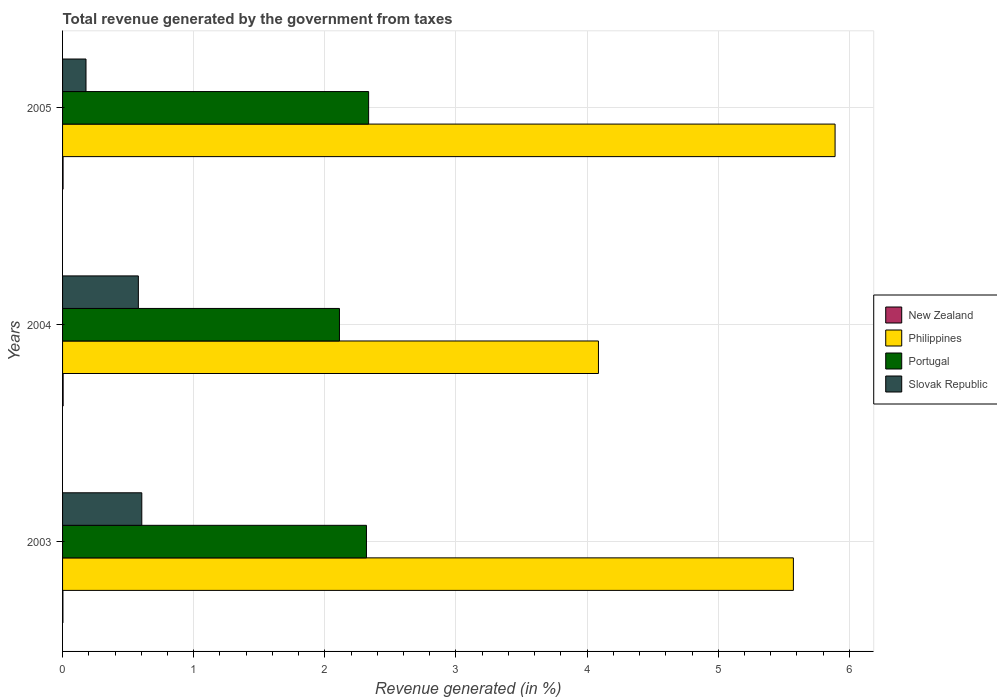How many different coloured bars are there?
Provide a succinct answer. 4. Are the number of bars per tick equal to the number of legend labels?
Offer a terse response. Yes. How many bars are there on the 2nd tick from the top?
Make the answer very short. 4. How many bars are there on the 1st tick from the bottom?
Your answer should be compact. 4. What is the label of the 2nd group of bars from the top?
Ensure brevity in your answer.  2004. What is the total revenue generated in New Zealand in 2004?
Your answer should be very brief. 0. Across all years, what is the maximum total revenue generated in Portugal?
Your answer should be compact. 2.33. Across all years, what is the minimum total revenue generated in Slovak Republic?
Make the answer very short. 0.18. In which year was the total revenue generated in New Zealand minimum?
Provide a short and direct response. 2003. What is the total total revenue generated in Philippines in the graph?
Your answer should be compact. 15.55. What is the difference between the total revenue generated in New Zealand in 2003 and that in 2005?
Your response must be concise. -0. What is the difference between the total revenue generated in Slovak Republic in 2005 and the total revenue generated in New Zealand in 2003?
Offer a terse response. 0.18. What is the average total revenue generated in Portugal per year?
Offer a very short reply. 2.25. In the year 2004, what is the difference between the total revenue generated in Slovak Republic and total revenue generated in New Zealand?
Your answer should be very brief. 0.57. In how many years, is the total revenue generated in New Zealand greater than 5.4 %?
Offer a very short reply. 0. What is the ratio of the total revenue generated in Philippines in 2003 to that in 2005?
Offer a terse response. 0.95. Is the total revenue generated in New Zealand in 2003 less than that in 2004?
Make the answer very short. Yes. What is the difference between the highest and the second highest total revenue generated in Portugal?
Ensure brevity in your answer.  0.02. What is the difference between the highest and the lowest total revenue generated in New Zealand?
Your answer should be very brief. 0. Is the sum of the total revenue generated in Philippines in 2003 and 2004 greater than the maximum total revenue generated in New Zealand across all years?
Your answer should be very brief. Yes. Is it the case that in every year, the sum of the total revenue generated in Philippines and total revenue generated in Portugal is greater than the sum of total revenue generated in Slovak Republic and total revenue generated in New Zealand?
Your answer should be compact. Yes. What does the 4th bar from the top in 2005 represents?
Give a very brief answer. New Zealand. What does the 4th bar from the bottom in 2005 represents?
Keep it short and to the point. Slovak Republic. Is it the case that in every year, the sum of the total revenue generated in Slovak Republic and total revenue generated in Philippines is greater than the total revenue generated in Portugal?
Your response must be concise. Yes. How many bars are there?
Offer a terse response. 12. How many years are there in the graph?
Provide a short and direct response. 3. What is the difference between two consecutive major ticks on the X-axis?
Your answer should be compact. 1. Are the values on the major ticks of X-axis written in scientific E-notation?
Ensure brevity in your answer.  No. Does the graph contain any zero values?
Make the answer very short. No. Does the graph contain grids?
Make the answer very short. Yes. What is the title of the graph?
Make the answer very short. Total revenue generated by the government from taxes. Does "Switzerland" appear as one of the legend labels in the graph?
Offer a terse response. No. What is the label or title of the X-axis?
Keep it short and to the point. Revenue generated (in %). What is the label or title of the Y-axis?
Your response must be concise. Years. What is the Revenue generated (in %) of New Zealand in 2003?
Your response must be concise. 0. What is the Revenue generated (in %) of Philippines in 2003?
Your response must be concise. 5.57. What is the Revenue generated (in %) in Portugal in 2003?
Offer a terse response. 2.32. What is the Revenue generated (in %) in Slovak Republic in 2003?
Ensure brevity in your answer.  0.6. What is the Revenue generated (in %) in New Zealand in 2004?
Offer a terse response. 0. What is the Revenue generated (in %) of Philippines in 2004?
Your answer should be compact. 4.09. What is the Revenue generated (in %) of Portugal in 2004?
Make the answer very short. 2.11. What is the Revenue generated (in %) in Slovak Republic in 2004?
Make the answer very short. 0.58. What is the Revenue generated (in %) in New Zealand in 2005?
Give a very brief answer. 0. What is the Revenue generated (in %) in Philippines in 2005?
Your answer should be very brief. 5.89. What is the Revenue generated (in %) in Portugal in 2005?
Make the answer very short. 2.33. What is the Revenue generated (in %) in Slovak Republic in 2005?
Keep it short and to the point. 0.18. Across all years, what is the maximum Revenue generated (in %) in New Zealand?
Your answer should be very brief. 0. Across all years, what is the maximum Revenue generated (in %) in Philippines?
Ensure brevity in your answer.  5.89. Across all years, what is the maximum Revenue generated (in %) of Portugal?
Give a very brief answer. 2.33. Across all years, what is the maximum Revenue generated (in %) of Slovak Republic?
Offer a terse response. 0.6. Across all years, what is the minimum Revenue generated (in %) in New Zealand?
Your answer should be compact. 0. Across all years, what is the minimum Revenue generated (in %) in Philippines?
Offer a very short reply. 4.09. Across all years, what is the minimum Revenue generated (in %) in Portugal?
Keep it short and to the point. 2.11. Across all years, what is the minimum Revenue generated (in %) of Slovak Republic?
Provide a short and direct response. 0.18. What is the total Revenue generated (in %) in New Zealand in the graph?
Your answer should be very brief. 0.01. What is the total Revenue generated (in %) of Philippines in the graph?
Keep it short and to the point. 15.55. What is the total Revenue generated (in %) of Portugal in the graph?
Offer a terse response. 6.76. What is the total Revenue generated (in %) in Slovak Republic in the graph?
Keep it short and to the point. 1.36. What is the difference between the Revenue generated (in %) of New Zealand in 2003 and that in 2004?
Your answer should be very brief. -0. What is the difference between the Revenue generated (in %) of Philippines in 2003 and that in 2004?
Your answer should be very brief. 1.49. What is the difference between the Revenue generated (in %) in Portugal in 2003 and that in 2004?
Your response must be concise. 0.21. What is the difference between the Revenue generated (in %) of Slovak Republic in 2003 and that in 2004?
Make the answer very short. 0.03. What is the difference between the Revenue generated (in %) in New Zealand in 2003 and that in 2005?
Provide a short and direct response. -0. What is the difference between the Revenue generated (in %) in Philippines in 2003 and that in 2005?
Your answer should be very brief. -0.32. What is the difference between the Revenue generated (in %) of Portugal in 2003 and that in 2005?
Ensure brevity in your answer.  -0.02. What is the difference between the Revenue generated (in %) in Slovak Republic in 2003 and that in 2005?
Provide a succinct answer. 0.43. What is the difference between the Revenue generated (in %) in New Zealand in 2004 and that in 2005?
Offer a terse response. 0. What is the difference between the Revenue generated (in %) in Philippines in 2004 and that in 2005?
Provide a short and direct response. -1.8. What is the difference between the Revenue generated (in %) of Portugal in 2004 and that in 2005?
Your response must be concise. -0.22. What is the difference between the Revenue generated (in %) of Slovak Republic in 2004 and that in 2005?
Your answer should be compact. 0.4. What is the difference between the Revenue generated (in %) of New Zealand in 2003 and the Revenue generated (in %) of Philippines in 2004?
Provide a succinct answer. -4.08. What is the difference between the Revenue generated (in %) in New Zealand in 2003 and the Revenue generated (in %) in Portugal in 2004?
Keep it short and to the point. -2.11. What is the difference between the Revenue generated (in %) in New Zealand in 2003 and the Revenue generated (in %) in Slovak Republic in 2004?
Offer a terse response. -0.58. What is the difference between the Revenue generated (in %) in Philippines in 2003 and the Revenue generated (in %) in Portugal in 2004?
Provide a short and direct response. 3.46. What is the difference between the Revenue generated (in %) in Philippines in 2003 and the Revenue generated (in %) in Slovak Republic in 2004?
Your response must be concise. 5. What is the difference between the Revenue generated (in %) of Portugal in 2003 and the Revenue generated (in %) of Slovak Republic in 2004?
Ensure brevity in your answer.  1.74. What is the difference between the Revenue generated (in %) in New Zealand in 2003 and the Revenue generated (in %) in Philippines in 2005?
Make the answer very short. -5.89. What is the difference between the Revenue generated (in %) in New Zealand in 2003 and the Revenue generated (in %) in Portugal in 2005?
Your answer should be very brief. -2.33. What is the difference between the Revenue generated (in %) of New Zealand in 2003 and the Revenue generated (in %) of Slovak Republic in 2005?
Ensure brevity in your answer.  -0.18. What is the difference between the Revenue generated (in %) in Philippines in 2003 and the Revenue generated (in %) in Portugal in 2005?
Your answer should be compact. 3.24. What is the difference between the Revenue generated (in %) in Philippines in 2003 and the Revenue generated (in %) in Slovak Republic in 2005?
Provide a short and direct response. 5.39. What is the difference between the Revenue generated (in %) in Portugal in 2003 and the Revenue generated (in %) in Slovak Republic in 2005?
Your response must be concise. 2.14. What is the difference between the Revenue generated (in %) in New Zealand in 2004 and the Revenue generated (in %) in Philippines in 2005?
Provide a succinct answer. -5.89. What is the difference between the Revenue generated (in %) of New Zealand in 2004 and the Revenue generated (in %) of Portugal in 2005?
Offer a terse response. -2.33. What is the difference between the Revenue generated (in %) of New Zealand in 2004 and the Revenue generated (in %) of Slovak Republic in 2005?
Give a very brief answer. -0.17. What is the difference between the Revenue generated (in %) in Philippines in 2004 and the Revenue generated (in %) in Portugal in 2005?
Give a very brief answer. 1.75. What is the difference between the Revenue generated (in %) of Philippines in 2004 and the Revenue generated (in %) of Slovak Republic in 2005?
Provide a short and direct response. 3.91. What is the difference between the Revenue generated (in %) in Portugal in 2004 and the Revenue generated (in %) in Slovak Republic in 2005?
Make the answer very short. 1.93. What is the average Revenue generated (in %) of New Zealand per year?
Your response must be concise. 0. What is the average Revenue generated (in %) in Philippines per year?
Offer a terse response. 5.18. What is the average Revenue generated (in %) in Portugal per year?
Your answer should be compact. 2.25. What is the average Revenue generated (in %) of Slovak Republic per year?
Your answer should be very brief. 0.45. In the year 2003, what is the difference between the Revenue generated (in %) in New Zealand and Revenue generated (in %) in Philippines?
Provide a short and direct response. -5.57. In the year 2003, what is the difference between the Revenue generated (in %) of New Zealand and Revenue generated (in %) of Portugal?
Give a very brief answer. -2.31. In the year 2003, what is the difference between the Revenue generated (in %) of New Zealand and Revenue generated (in %) of Slovak Republic?
Your answer should be compact. -0.6. In the year 2003, what is the difference between the Revenue generated (in %) in Philippines and Revenue generated (in %) in Portugal?
Your answer should be compact. 3.26. In the year 2003, what is the difference between the Revenue generated (in %) in Philippines and Revenue generated (in %) in Slovak Republic?
Give a very brief answer. 4.97. In the year 2003, what is the difference between the Revenue generated (in %) in Portugal and Revenue generated (in %) in Slovak Republic?
Your response must be concise. 1.71. In the year 2004, what is the difference between the Revenue generated (in %) in New Zealand and Revenue generated (in %) in Philippines?
Make the answer very short. -4.08. In the year 2004, what is the difference between the Revenue generated (in %) in New Zealand and Revenue generated (in %) in Portugal?
Provide a succinct answer. -2.11. In the year 2004, what is the difference between the Revenue generated (in %) in New Zealand and Revenue generated (in %) in Slovak Republic?
Your answer should be compact. -0.57. In the year 2004, what is the difference between the Revenue generated (in %) in Philippines and Revenue generated (in %) in Portugal?
Your response must be concise. 1.98. In the year 2004, what is the difference between the Revenue generated (in %) of Philippines and Revenue generated (in %) of Slovak Republic?
Your answer should be very brief. 3.51. In the year 2004, what is the difference between the Revenue generated (in %) of Portugal and Revenue generated (in %) of Slovak Republic?
Provide a short and direct response. 1.53. In the year 2005, what is the difference between the Revenue generated (in %) of New Zealand and Revenue generated (in %) of Philippines?
Keep it short and to the point. -5.89. In the year 2005, what is the difference between the Revenue generated (in %) in New Zealand and Revenue generated (in %) in Portugal?
Offer a very short reply. -2.33. In the year 2005, what is the difference between the Revenue generated (in %) of New Zealand and Revenue generated (in %) of Slovak Republic?
Your response must be concise. -0.17. In the year 2005, what is the difference between the Revenue generated (in %) in Philippines and Revenue generated (in %) in Portugal?
Offer a terse response. 3.56. In the year 2005, what is the difference between the Revenue generated (in %) of Philippines and Revenue generated (in %) of Slovak Republic?
Make the answer very short. 5.71. In the year 2005, what is the difference between the Revenue generated (in %) of Portugal and Revenue generated (in %) of Slovak Republic?
Your response must be concise. 2.16. What is the ratio of the Revenue generated (in %) in New Zealand in 2003 to that in 2004?
Offer a very short reply. 0.62. What is the ratio of the Revenue generated (in %) of Philippines in 2003 to that in 2004?
Offer a terse response. 1.36. What is the ratio of the Revenue generated (in %) of Portugal in 2003 to that in 2004?
Provide a short and direct response. 1.1. What is the ratio of the Revenue generated (in %) of Slovak Republic in 2003 to that in 2004?
Give a very brief answer. 1.05. What is the ratio of the Revenue generated (in %) of New Zealand in 2003 to that in 2005?
Make the answer very short. 0.69. What is the ratio of the Revenue generated (in %) of Philippines in 2003 to that in 2005?
Your answer should be very brief. 0.95. What is the ratio of the Revenue generated (in %) of Portugal in 2003 to that in 2005?
Ensure brevity in your answer.  0.99. What is the ratio of the Revenue generated (in %) in Slovak Republic in 2003 to that in 2005?
Your answer should be compact. 3.38. What is the ratio of the Revenue generated (in %) in New Zealand in 2004 to that in 2005?
Provide a short and direct response. 1.11. What is the ratio of the Revenue generated (in %) of Philippines in 2004 to that in 2005?
Provide a short and direct response. 0.69. What is the ratio of the Revenue generated (in %) in Portugal in 2004 to that in 2005?
Give a very brief answer. 0.9. What is the ratio of the Revenue generated (in %) in Slovak Republic in 2004 to that in 2005?
Make the answer very short. 3.23. What is the difference between the highest and the second highest Revenue generated (in %) in New Zealand?
Offer a very short reply. 0. What is the difference between the highest and the second highest Revenue generated (in %) of Philippines?
Your answer should be very brief. 0.32. What is the difference between the highest and the second highest Revenue generated (in %) in Portugal?
Offer a terse response. 0.02. What is the difference between the highest and the second highest Revenue generated (in %) of Slovak Republic?
Your response must be concise. 0.03. What is the difference between the highest and the lowest Revenue generated (in %) in New Zealand?
Give a very brief answer. 0. What is the difference between the highest and the lowest Revenue generated (in %) of Philippines?
Offer a very short reply. 1.8. What is the difference between the highest and the lowest Revenue generated (in %) in Portugal?
Provide a short and direct response. 0.22. What is the difference between the highest and the lowest Revenue generated (in %) in Slovak Republic?
Offer a terse response. 0.43. 